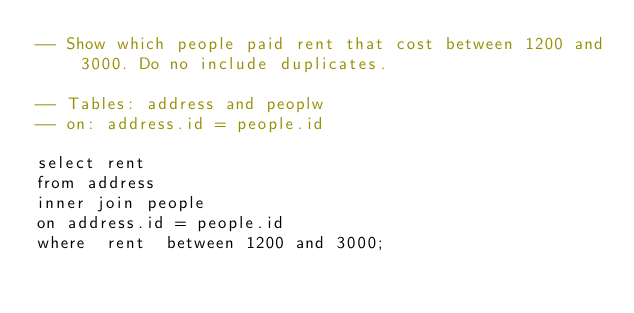<code> <loc_0><loc_0><loc_500><loc_500><_SQL_>-- Show which people paid rent that cost between 1200 and 3000. Do no include duplicates.

-- Tables: address and peoplw
-- on: address.id = people.id

select rent
from address
inner join people
on address.id = people.id
where  rent  between 1200 and 3000;

</code> 